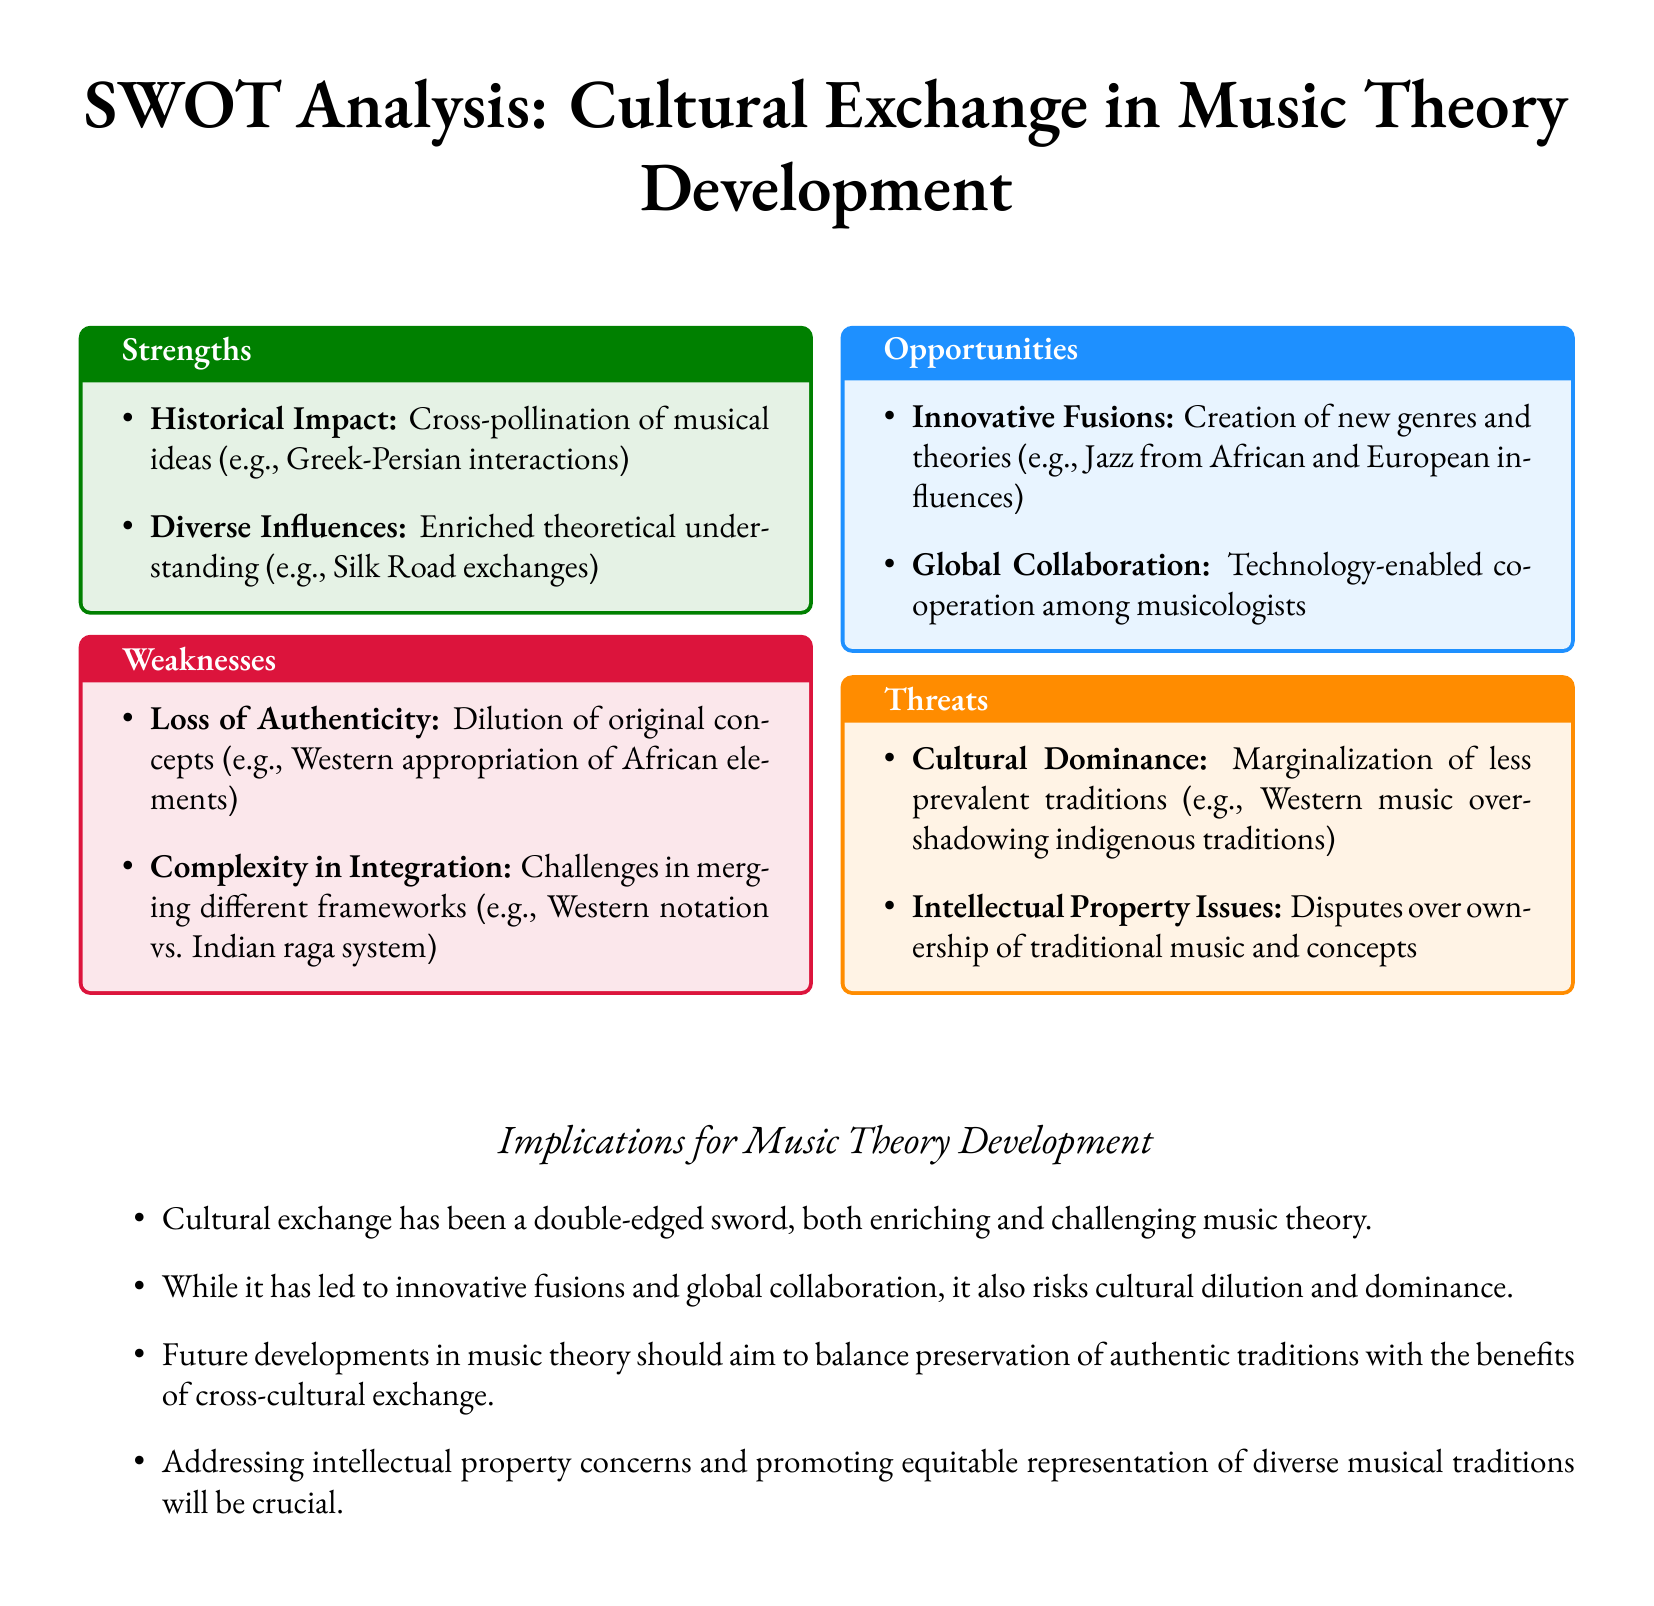What is one historical example of cultural exchange in music? The document mentions the Greek-Persian interactions as a historical impact of cultural exchange in music.
Answer: Greek-Persian interactions What does the SWOT analysis list as a threat to music theory? The document identifies cultural dominance as a threat to music theory development.
Answer: Cultural dominance What is noted as a strength of cultural exchange in music theory development? The cross-pollination of musical ideas is highlighted as a strength in the SWOT analysis.
Answer: Cross-pollination of musical ideas What opportunity for music theory is mentioned in the SWOT analysis? The creation of new genres and theories from innovative fusions is noted as an opportunity.
Answer: Innovative fusions What is a specific weakness related to cultural exchange? The document states that the dilution of original concepts is a weakness of cultural exchange in music theory.
Answer: Dilution of original concepts How does cultural exchange impact music theory development according to the document? The document describes cultural exchange as a double-edged sword, providing both enrichment and challenges.
Answer: Double-edged sword What theme is emphasized for future music theory development? The document emphasizes the need to balance preservation of authentic traditions with cross-cultural exchange benefits.
Answer: Balance preservation and benefits What element can facilitate global collaboration in musicology? The document indicates that technology is a key element enabling cooperation among musicologists.
Answer: Technology What is a major concern regarding traditional music mentioned in the SWOT analysis? The document raises intellectual property issues as a major concern regarding traditional music.
Answer: Intellectual property issues 